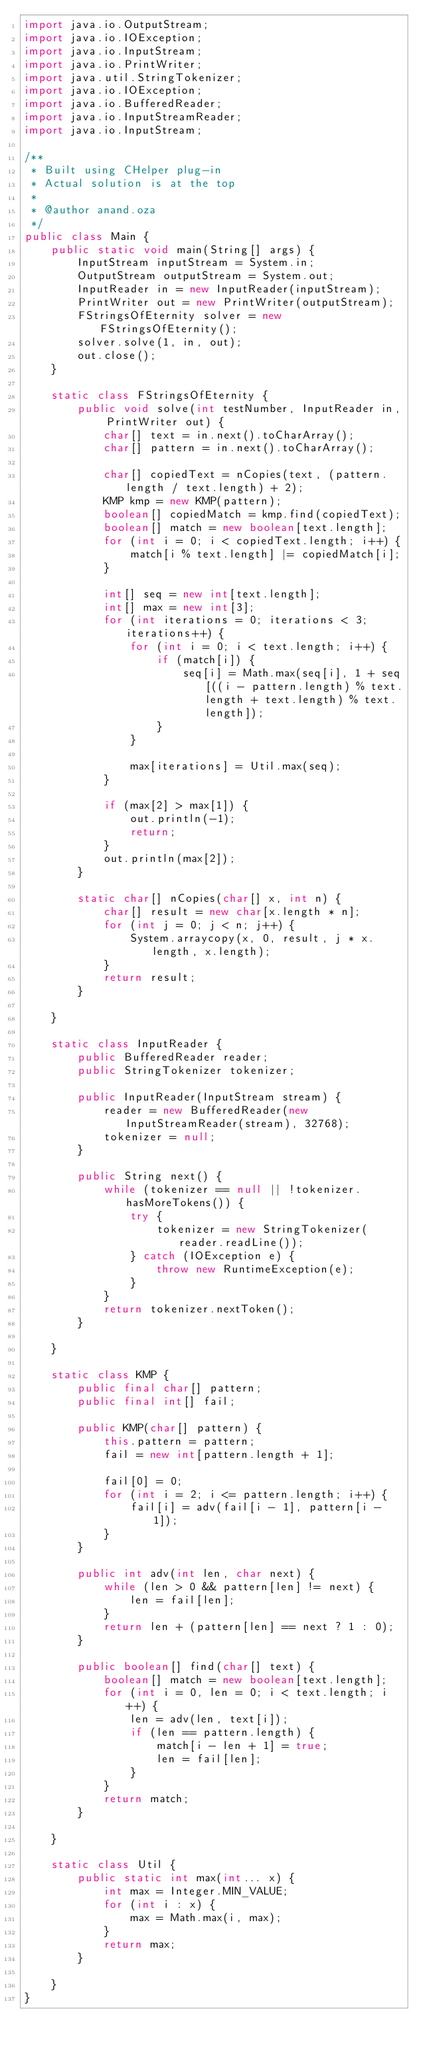<code> <loc_0><loc_0><loc_500><loc_500><_Java_>import java.io.OutputStream;
import java.io.IOException;
import java.io.InputStream;
import java.io.PrintWriter;
import java.util.StringTokenizer;
import java.io.IOException;
import java.io.BufferedReader;
import java.io.InputStreamReader;
import java.io.InputStream;

/**
 * Built using CHelper plug-in
 * Actual solution is at the top
 *
 * @author anand.oza
 */
public class Main {
    public static void main(String[] args) {
        InputStream inputStream = System.in;
        OutputStream outputStream = System.out;
        InputReader in = new InputReader(inputStream);
        PrintWriter out = new PrintWriter(outputStream);
        FStringsOfEternity solver = new FStringsOfEternity();
        solver.solve(1, in, out);
        out.close();
    }

    static class FStringsOfEternity {
        public void solve(int testNumber, InputReader in, PrintWriter out) {
            char[] text = in.next().toCharArray();
            char[] pattern = in.next().toCharArray();

            char[] copiedText = nCopies(text, (pattern.length / text.length) + 2);
            KMP kmp = new KMP(pattern);
            boolean[] copiedMatch = kmp.find(copiedText);
            boolean[] match = new boolean[text.length];
            for (int i = 0; i < copiedText.length; i++) {
                match[i % text.length] |= copiedMatch[i];
            }

            int[] seq = new int[text.length];
            int[] max = new int[3];
            for (int iterations = 0; iterations < 3; iterations++) {
                for (int i = 0; i < text.length; i++) {
                    if (match[i]) {
                        seq[i] = Math.max(seq[i], 1 + seq[((i - pattern.length) % text.length + text.length) % text.length]);
                    }
                }

                max[iterations] = Util.max(seq);
            }

            if (max[2] > max[1]) {
                out.println(-1);
                return;
            }
            out.println(max[2]);
        }

        static char[] nCopies(char[] x, int n) {
            char[] result = new char[x.length * n];
            for (int j = 0; j < n; j++) {
                System.arraycopy(x, 0, result, j * x.length, x.length);
            }
            return result;
        }

    }

    static class InputReader {
        public BufferedReader reader;
        public StringTokenizer tokenizer;

        public InputReader(InputStream stream) {
            reader = new BufferedReader(new InputStreamReader(stream), 32768);
            tokenizer = null;
        }

        public String next() {
            while (tokenizer == null || !tokenizer.hasMoreTokens()) {
                try {
                    tokenizer = new StringTokenizer(reader.readLine());
                } catch (IOException e) {
                    throw new RuntimeException(e);
                }
            }
            return tokenizer.nextToken();
        }

    }

    static class KMP {
        public final char[] pattern;
        public final int[] fail;

        public KMP(char[] pattern) {
            this.pattern = pattern;
            fail = new int[pattern.length + 1];

            fail[0] = 0;
            for (int i = 2; i <= pattern.length; i++) {
                fail[i] = adv(fail[i - 1], pattern[i - 1]);
            }
        }

        public int adv(int len, char next) {
            while (len > 0 && pattern[len] != next) {
                len = fail[len];
            }
            return len + (pattern[len] == next ? 1 : 0);
        }

        public boolean[] find(char[] text) {
            boolean[] match = new boolean[text.length];
            for (int i = 0, len = 0; i < text.length; i++) {
                len = adv(len, text[i]);
                if (len == pattern.length) {
                    match[i - len + 1] = true;
                    len = fail[len];
                }
            }
            return match;
        }

    }

    static class Util {
        public static int max(int... x) {
            int max = Integer.MIN_VALUE;
            for (int i : x) {
                max = Math.max(i, max);
            }
            return max;
        }

    }
}

</code> 